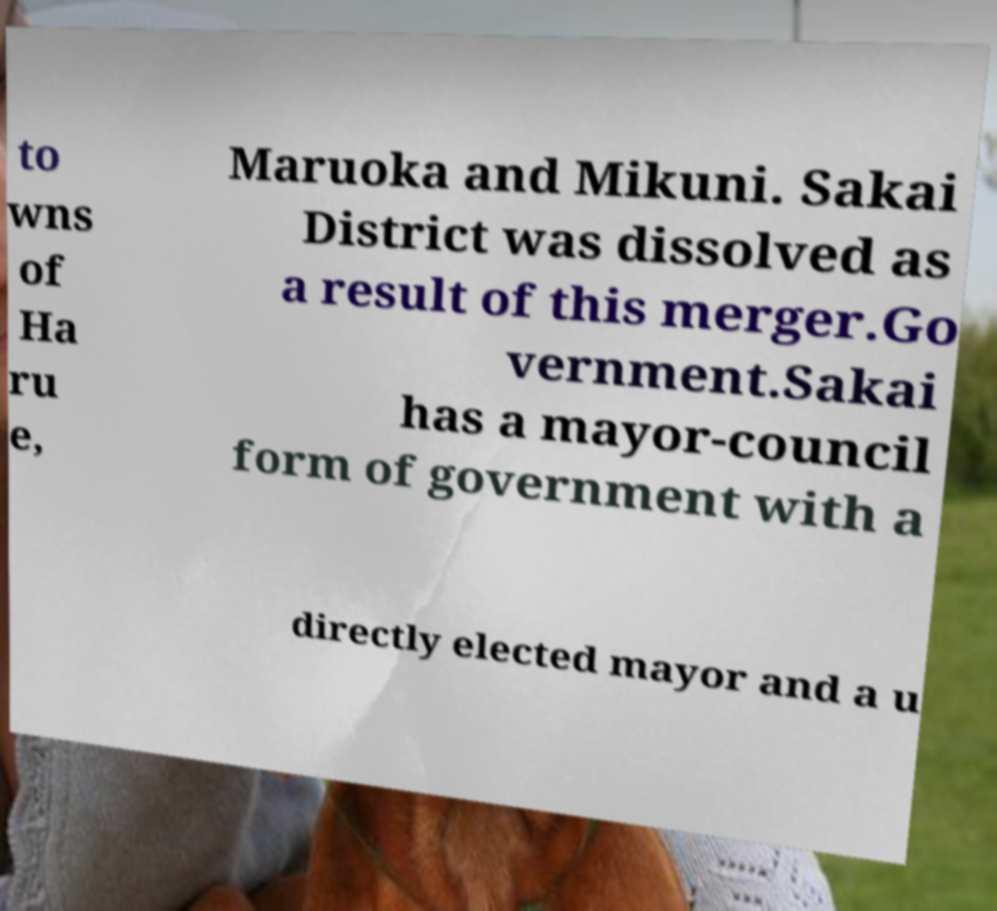I need the written content from this picture converted into text. Can you do that? to wns of Ha ru e, Maruoka and Mikuni. Sakai District was dissolved as a result of this merger.Go vernment.Sakai has a mayor-council form of government with a directly elected mayor and a u 